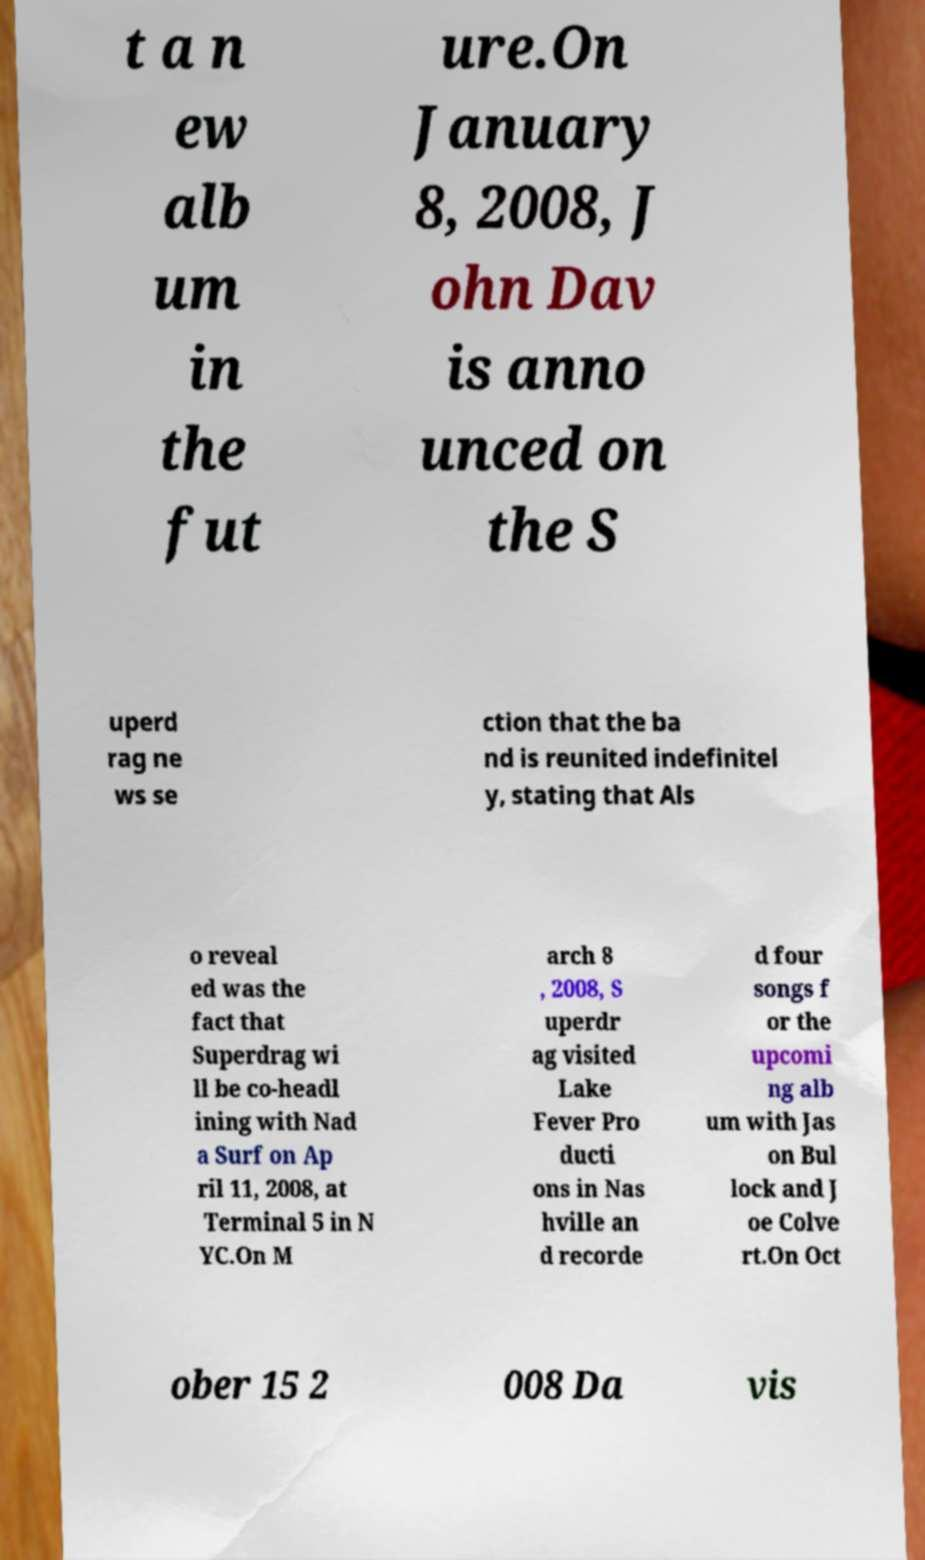Can you accurately transcribe the text from the provided image for me? t a n ew alb um in the fut ure.On January 8, 2008, J ohn Dav is anno unced on the S uperd rag ne ws se ction that the ba nd is reunited indefinitel y, stating that Als o reveal ed was the fact that Superdrag wi ll be co-headl ining with Nad a Surf on Ap ril 11, 2008, at Terminal 5 in N YC.On M arch 8 , 2008, S uperdr ag visited Lake Fever Pro ducti ons in Nas hville an d recorde d four songs f or the upcomi ng alb um with Jas on Bul lock and J oe Colve rt.On Oct ober 15 2 008 Da vis 